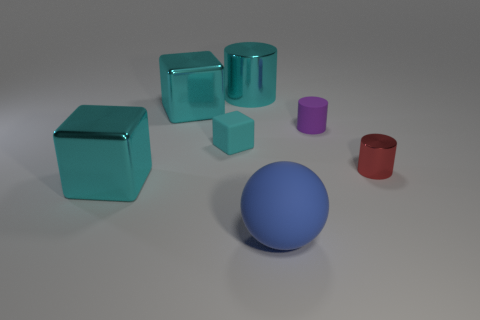There is a cyan metal block that is behind the metallic thing that is on the right side of the big cyan cylinder; how many red metal objects are left of it? 0 